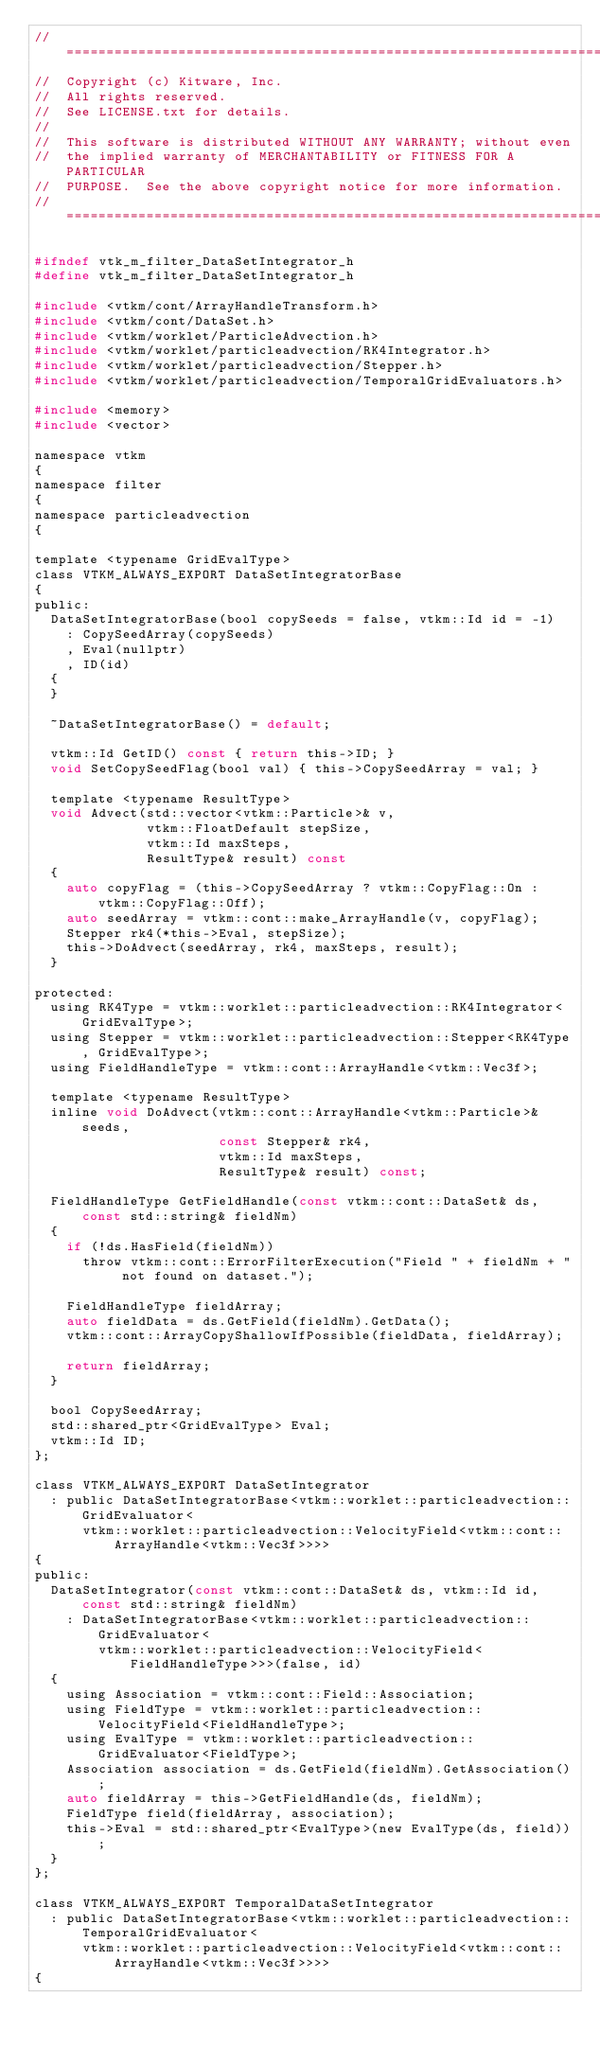Convert code to text. <code><loc_0><loc_0><loc_500><loc_500><_C_>//============================================================================
//  Copyright (c) Kitware, Inc.
//  All rights reserved.
//  See LICENSE.txt for details.
//
//  This software is distributed WITHOUT ANY WARRANTY; without even
//  the implied warranty of MERCHANTABILITY or FITNESS FOR A PARTICULAR
//  PURPOSE.  See the above copyright notice for more information.
//============================================================================

#ifndef vtk_m_filter_DataSetIntegrator_h
#define vtk_m_filter_DataSetIntegrator_h

#include <vtkm/cont/ArrayHandleTransform.h>
#include <vtkm/cont/DataSet.h>
#include <vtkm/worklet/ParticleAdvection.h>
#include <vtkm/worklet/particleadvection/RK4Integrator.h>
#include <vtkm/worklet/particleadvection/Stepper.h>
#include <vtkm/worklet/particleadvection/TemporalGridEvaluators.h>

#include <memory>
#include <vector>

namespace vtkm
{
namespace filter
{
namespace particleadvection
{

template <typename GridEvalType>
class VTKM_ALWAYS_EXPORT DataSetIntegratorBase
{
public:
  DataSetIntegratorBase(bool copySeeds = false, vtkm::Id id = -1)
    : CopySeedArray(copySeeds)
    , Eval(nullptr)
    , ID(id)
  {
  }

  ~DataSetIntegratorBase() = default;

  vtkm::Id GetID() const { return this->ID; }
  void SetCopySeedFlag(bool val) { this->CopySeedArray = val; }

  template <typename ResultType>
  void Advect(std::vector<vtkm::Particle>& v,
              vtkm::FloatDefault stepSize,
              vtkm::Id maxSteps,
              ResultType& result) const
  {
    auto copyFlag = (this->CopySeedArray ? vtkm::CopyFlag::On : vtkm::CopyFlag::Off);
    auto seedArray = vtkm::cont::make_ArrayHandle(v, copyFlag);
    Stepper rk4(*this->Eval, stepSize);
    this->DoAdvect(seedArray, rk4, maxSteps, result);
  }

protected:
  using RK4Type = vtkm::worklet::particleadvection::RK4Integrator<GridEvalType>;
  using Stepper = vtkm::worklet::particleadvection::Stepper<RK4Type, GridEvalType>;
  using FieldHandleType = vtkm::cont::ArrayHandle<vtkm::Vec3f>;

  template <typename ResultType>
  inline void DoAdvect(vtkm::cont::ArrayHandle<vtkm::Particle>& seeds,
                       const Stepper& rk4,
                       vtkm::Id maxSteps,
                       ResultType& result) const;

  FieldHandleType GetFieldHandle(const vtkm::cont::DataSet& ds, const std::string& fieldNm)
  {
    if (!ds.HasField(fieldNm))
      throw vtkm::cont::ErrorFilterExecution("Field " + fieldNm + " not found on dataset.");

    FieldHandleType fieldArray;
    auto fieldData = ds.GetField(fieldNm).GetData();
    vtkm::cont::ArrayCopyShallowIfPossible(fieldData, fieldArray);

    return fieldArray;
  }

  bool CopySeedArray;
  std::shared_ptr<GridEvalType> Eval;
  vtkm::Id ID;
};

class VTKM_ALWAYS_EXPORT DataSetIntegrator
  : public DataSetIntegratorBase<vtkm::worklet::particleadvection::GridEvaluator<
      vtkm::worklet::particleadvection::VelocityField<vtkm::cont::ArrayHandle<vtkm::Vec3f>>>>
{
public:
  DataSetIntegrator(const vtkm::cont::DataSet& ds, vtkm::Id id, const std::string& fieldNm)
    : DataSetIntegratorBase<vtkm::worklet::particleadvection::GridEvaluator<
        vtkm::worklet::particleadvection::VelocityField<FieldHandleType>>>(false, id)
  {
    using Association = vtkm::cont::Field::Association;
    using FieldType = vtkm::worklet::particleadvection::VelocityField<FieldHandleType>;
    using EvalType = vtkm::worklet::particleadvection::GridEvaluator<FieldType>;
    Association association = ds.GetField(fieldNm).GetAssociation();
    auto fieldArray = this->GetFieldHandle(ds, fieldNm);
    FieldType field(fieldArray, association);
    this->Eval = std::shared_ptr<EvalType>(new EvalType(ds, field));
  }
};

class VTKM_ALWAYS_EXPORT TemporalDataSetIntegrator
  : public DataSetIntegratorBase<vtkm::worklet::particleadvection::TemporalGridEvaluator<
      vtkm::worklet::particleadvection::VelocityField<vtkm::cont::ArrayHandle<vtkm::Vec3f>>>>
{</code> 